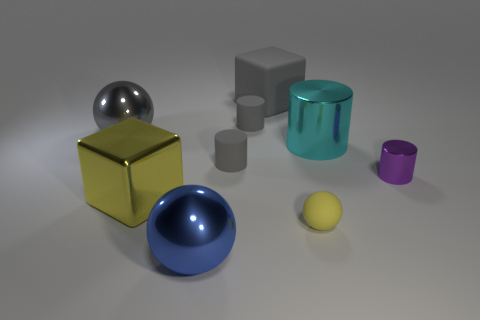Is there a tiny shiny thing of the same color as the large rubber thing?
Your answer should be very brief. No. What shape is the yellow object that is the same size as the purple cylinder?
Provide a succinct answer. Sphere. There is a tiny thing on the right side of the cyan object; what color is it?
Your response must be concise. Purple. Are there any shiny things that are in front of the yellow object in front of the large yellow metallic block?
Offer a terse response. Yes. How many things are metallic spheres behind the big blue metal sphere or big yellow things?
Provide a short and direct response. 2. The large ball right of the metallic ball behind the large cyan thing is made of what material?
Offer a terse response. Metal. Are there the same number of big shiny cubes on the right side of the large cyan metal cylinder and yellow metallic cubes behind the large yellow object?
Provide a short and direct response. Yes. What number of objects are either large metallic balls behind the large cyan cylinder or big metallic objects that are behind the purple cylinder?
Your answer should be very brief. 2. What is the material of the big thing that is on the left side of the tiny yellow ball and on the right side of the blue sphere?
Offer a terse response. Rubber. There is a sphere that is on the right side of the shiny ball that is in front of the cyan object that is right of the large yellow block; what size is it?
Give a very brief answer. Small. 